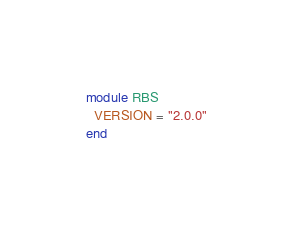Convert code to text. <code><loc_0><loc_0><loc_500><loc_500><_Ruby_>module RBS
  VERSION = "2.0.0"
end
</code> 